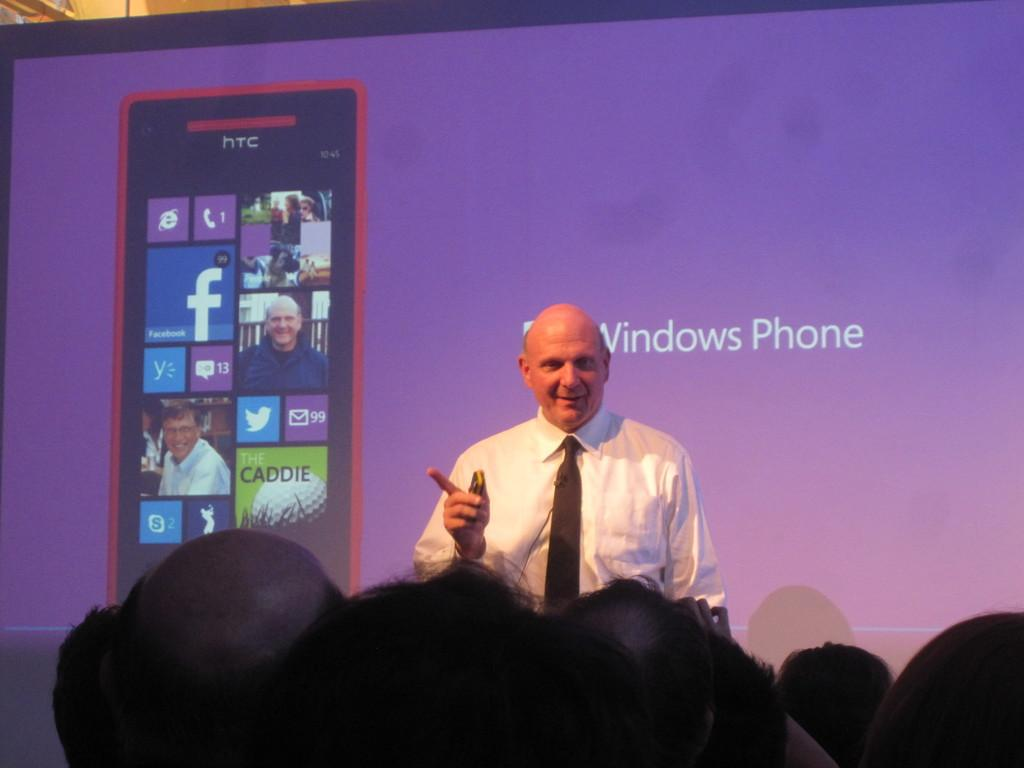Provide a one-sentence caption for the provided image. An old bald guy in front of people discussing about a Windows Phone. 